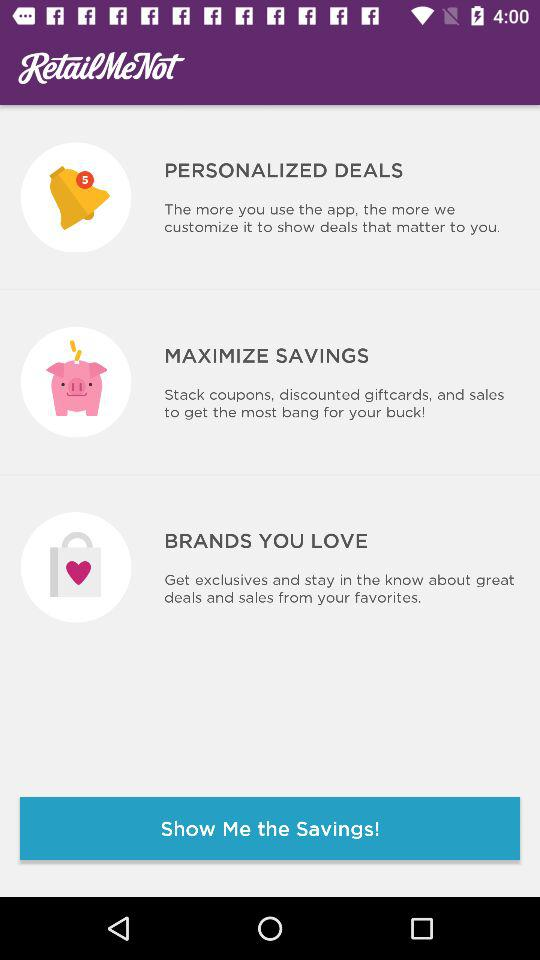What is "MAXIMIZE SAVINGS"? "MAXIMIZE SAVINGS" is "Stack coupons, discounted giftcards, and sales to get the most bang for your buck!". 